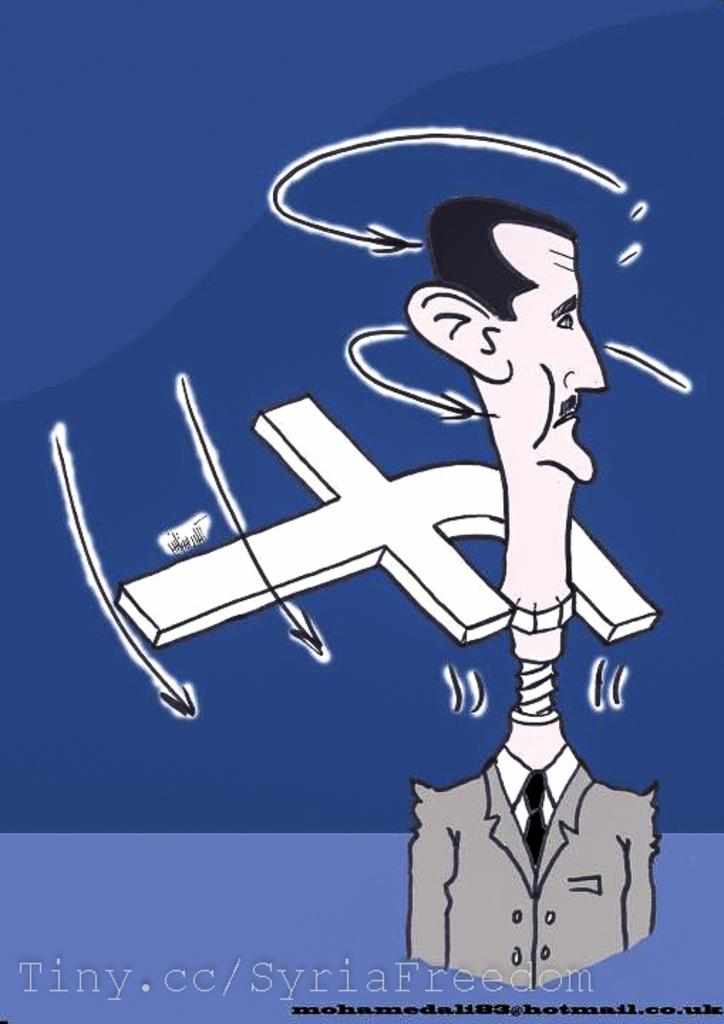<image>
Create a compact narrative representing the image presented. the word tiny is next to the funny cartoon 